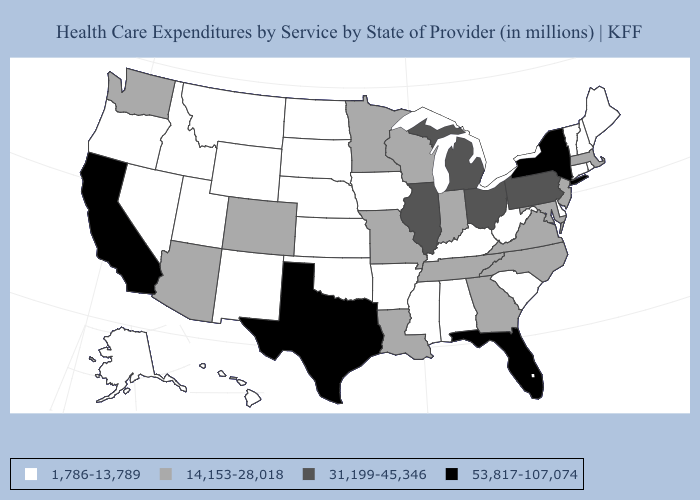What is the value of North Carolina?
Short answer required. 14,153-28,018. What is the highest value in the South ?
Write a very short answer. 53,817-107,074. What is the highest value in the USA?
Quick response, please. 53,817-107,074. Name the states that have a value in the range 53,817-107,074?
Short answer required. California, Florida, New York, Texas. Which states hav the highest value in the West?
Write a very short answer. California. What is the value of Wyoming?
Keep it brief. 1,786-13,789. Does Missouri have the lowest value in the MidWest?
Keep it brief. No. Does Massachusetts have the lowest value in the Northeast?
Answer briefly. No. Name the states that have a value in the range 1,786-13,789?
Keep it brief. Alabama, Alaska, Arkansas, Connecticut, Delaware, Hawaii, Idaho, Iowa, Kansas, Kentucky, Maine, Mississippi, Montana, Nebraska, Nevada, New Hampshire, New Mexico, North Dakota, Oklahoma, Oregon, Rhode Island, South Carolina, South Dakota, Utah, Vermont, West Virginia, Wyoming. Among the states that border Delaware , does Maryland have the lowest value?
Short answer required. Yes. What is the lowest value in states that border Delaware?
Quick response, please. 14,153-28,018. What is the lowest value in the USA?
Be succinct. 1,786-13,789. What is the value of Utah?
Write a very short answer. 1,786-13,789. Among the states that border Maine , which have the highest value?
Be succinct. New Hampshire. What is the value of Connecticut?
Keep it brief. 1,786-13,789. 